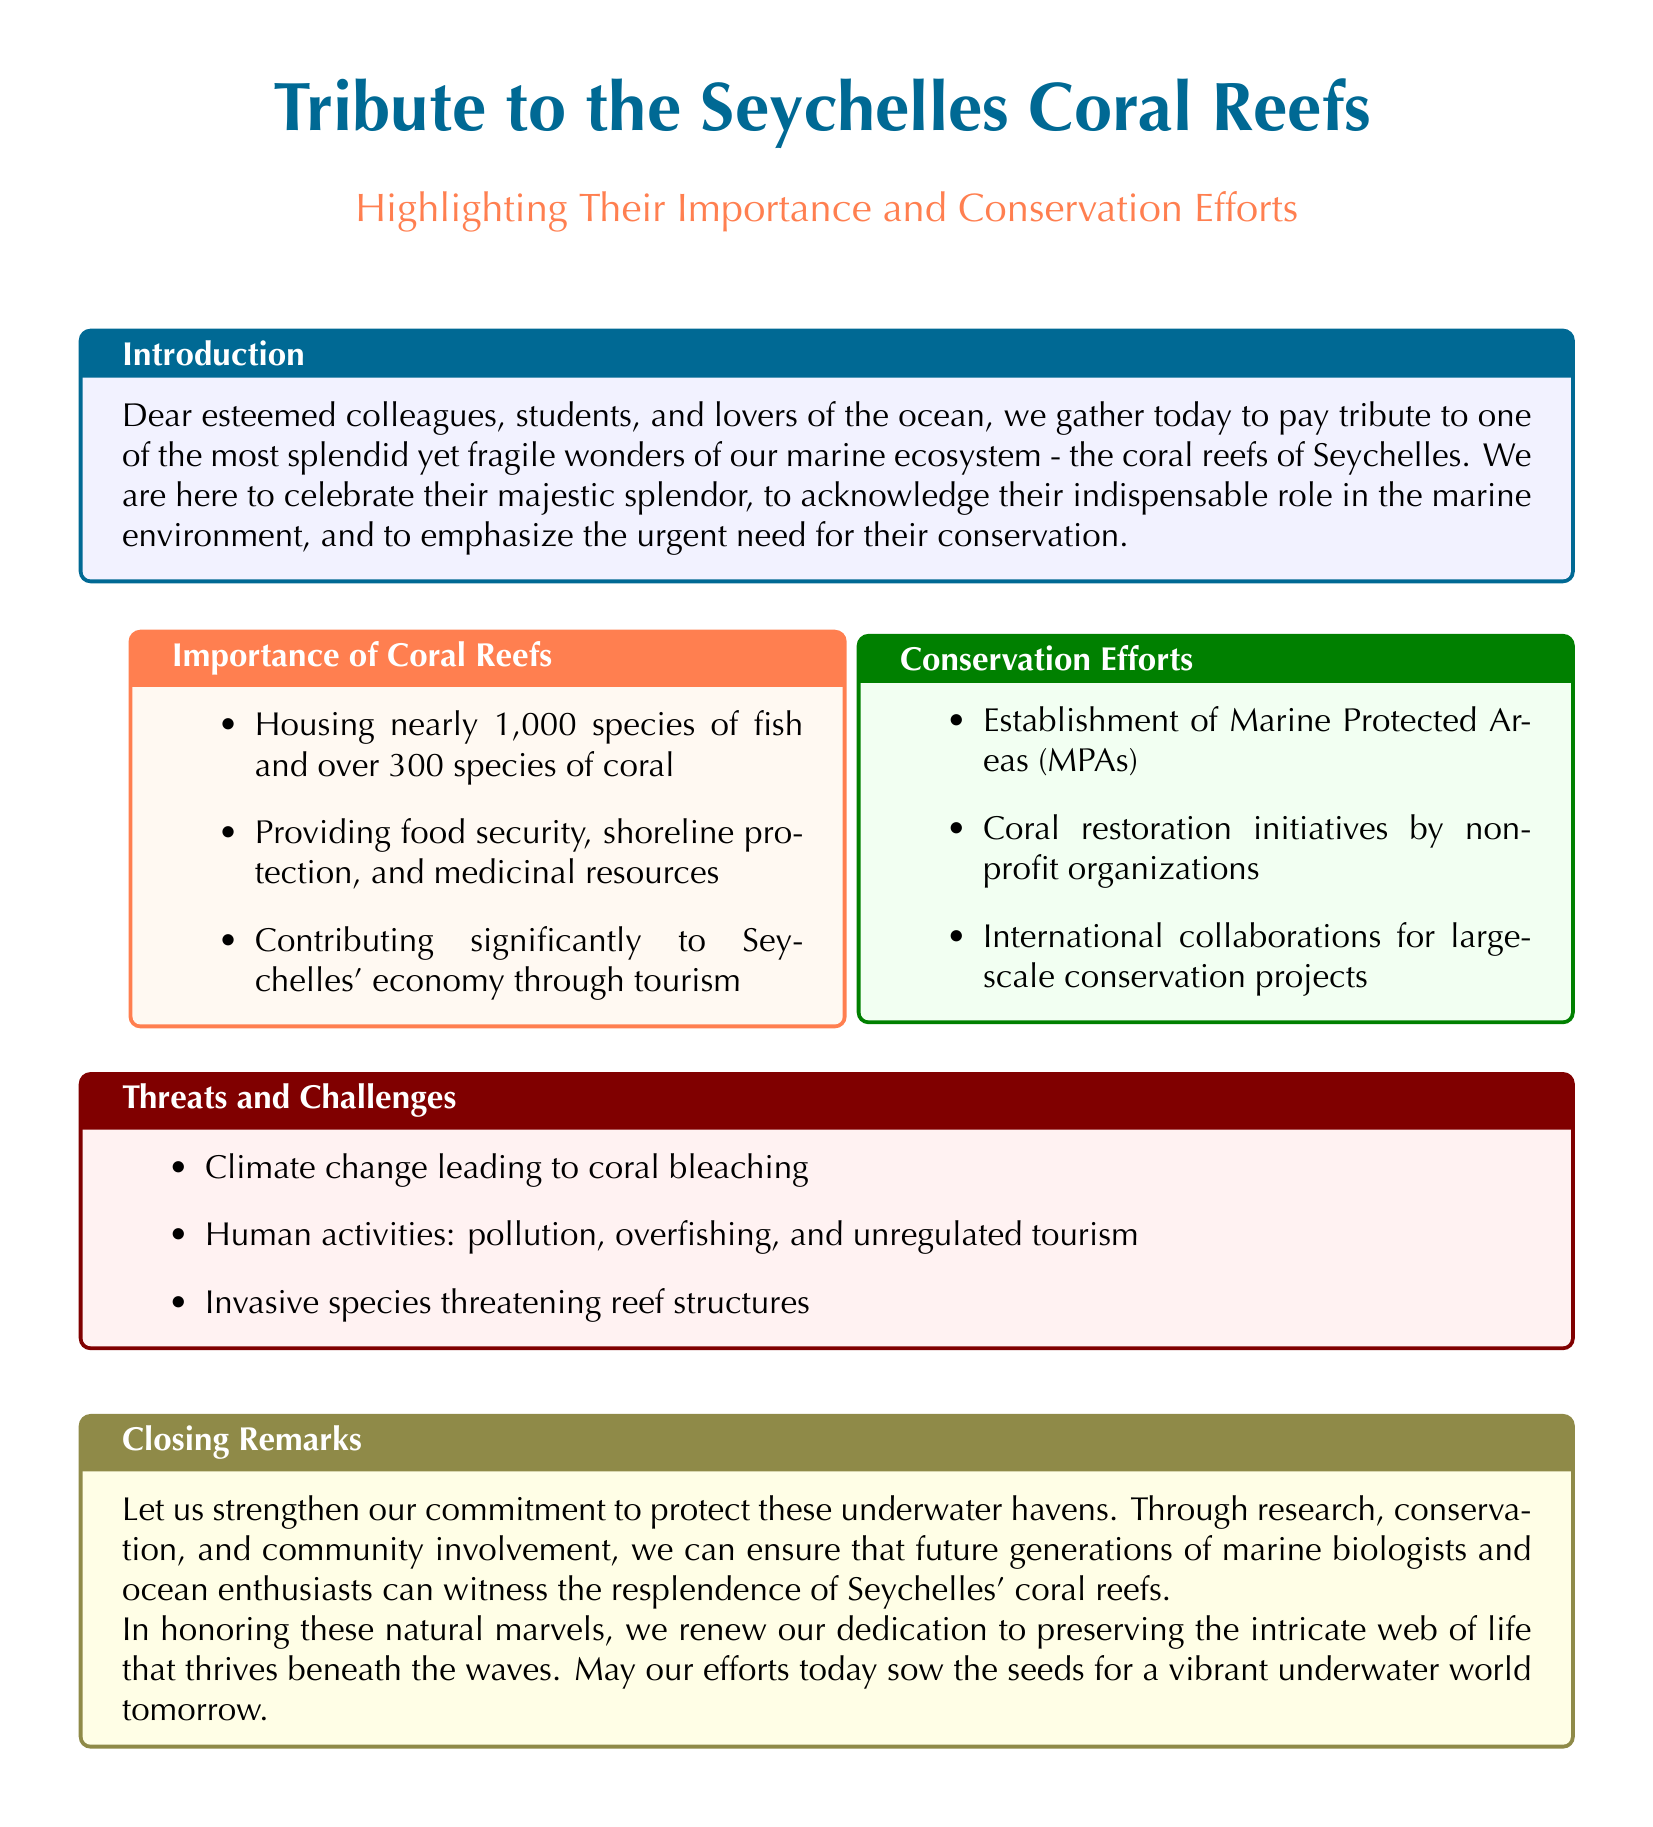What species of fish can be found in the coral reefs? The document states that nearly 1,000 species of fish are housed in the coral reefs.
Answer: 1,000 species How many species of coral are mentioned? The document specifically mentions that there are over 300 species of coral.
Answer: Over 300 species What is a significant economic contribution of the coral reefs? The document highlights that coral reefs contribute significantly to Seychelles' economy through tourism.
Answer: Tourism What are MPAs? The document refers to Marine Protected Areas as a conservation effort established to protect coral reefs.
Answer: Marine Protected Areas What is the biggest threat to coral reefs mentioned in the document? The document notes climate change leading to coral bleaching as a major threat to coral reefs.
Answer: Climate change What initiative is mentioned for coral restoration? Non-profit organizations are involved in coral restoration initiatives as stated in the document.
Answer: Non-profit organizations What action is recommended for protecting coral reefs? The document encourages strengthening commitment through research, conservation, and community involvement.
Answer: Research, conservation, and community involvement What is one of the human activities threatening coral reefs? The document points out pollution as one of the human activities threatening coral reefs.
Answer: Pollution What are the final remarks about the future of coral reefs? The document expresses hope that efforts today will ensure a vibrant underwater world tomorrow.
Answer: A vibrant underwater world tomorrow 